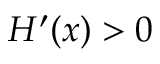Convert formula to latex. <formula><loc_0><loc_0><loc_500><loc_500>H ^ { \prime } ( x ) > 0</formula> 